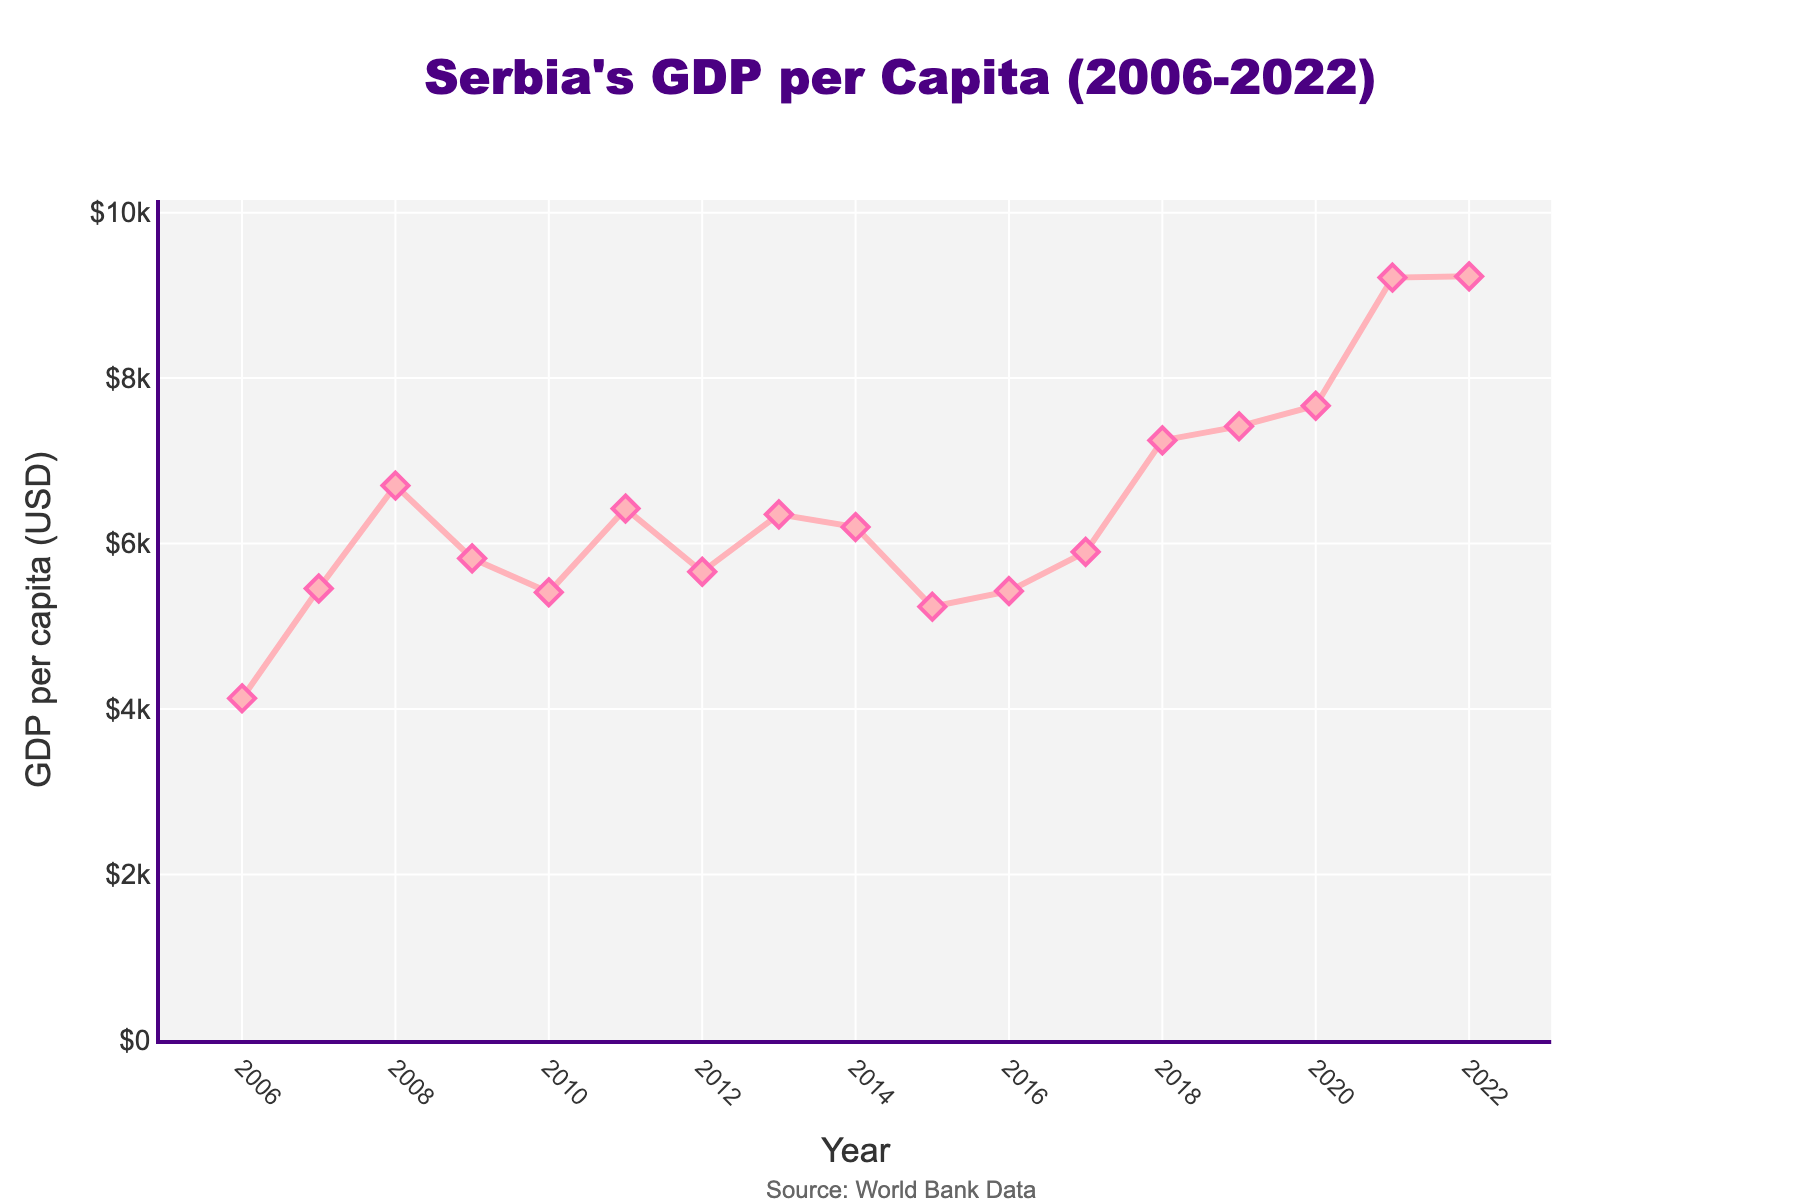What year shows the highest GDP per capita? The highest point on the line chart can be observed around the end of the timeframe. Check the years and their corresponding GDP values to find the peak. The year 2022 has the highest GDP per capita at $9230.
Answer: 2022 What is the difference in GDP per capita between 2008 and 2009? Locate the GDP values for the years 2008 and 2009 on the chart, then subtract the value for 2009 from the value for 2008. For 2008, GDP per capita is $6702 and for 2009, it is $5821. The difference is $6702 - $5821 = $881.
Answer: $881 Which year experienced the most significant drop in GDP per capita? Observe the line chart and identify where the downward slopes are steepest. The steepest decline appears between 2008 and 2009, from $6702 to $5821.
Answer: 2009 How many years did it take for the GDP per capita to recover to its 2008 value after its drop in 2009? The GDP per capita in 2008 was $6702. Check subsequent years until you find the GDP value equal or higher than $6702. The GDP per capita reached $7247 by 2018. Thus, it took 10 years (2018 - 2008).
Answer: 10 years What is the average GDP per capita from 2006 to 2012? Sum the GDP per capita values from 2006 to 2012 and divide by the number of years. The values are 4130, 5458, 6702, 5821, 5411, 6423, and 5659. The average is (4130 + 5458 + 6702 + 5821 + 5411 + 6423 + 5659) / 7 = 5657.71.
Answer: $5657.71 Does the GDP per capita always increase between consecutive years? Look at the line chart to see if every year shows a positive increase from the previous year. Notice the years 2009, 2010, 2012, 2014, and 2015 where GDP per capita decreased.
Answer: No What is the trend between 2019 and 2022, and by how much does it change? Check the GDP per capita values from 2019 to 2022. The values are 7417, 7666, 9215, and 9230. The trend shows an increase every year. The total change from 2019 to 2022 is 9230 - 7417 = $1813.
Answer: Increasing by $1813 Which year marked the biggest annual increase in GDP per capita and how much was it? Determine the increase in GDP per capita for each consecutive year and identify the largest jump. Compare the differences such as 2020 to 2021 which increased from $7666 to $9215, the increase is $1549, which is the largest.
Answer: 2021 with $1549 What was the overall percentage increase in GDP per capita from 2006 to 2022? Calculate the percentage increase using the formula ((final value - initial value) / initial value) * 100. The values are from $4130 in 2006 to $9230 in 2022. The overall increase is ((9230 - 4130) / 4130) * 100 ≈ 123.4%.
Answer: 123.4% What are the colors used for the line and markers on the chart? Notice the visual attributes for the line and markers in the chart. The line is a reddish-pink color and the markers are in a shade of hot pink with a diamond symbol.
Answer: Reddish-pink and hot pink 